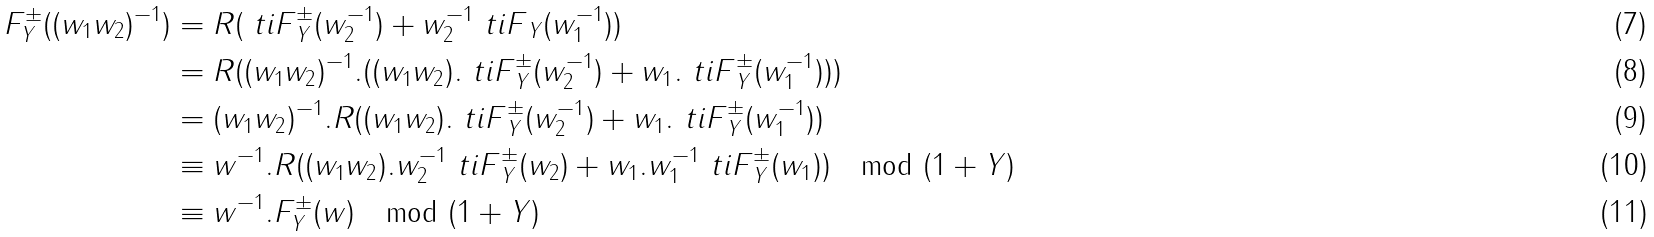<formula> <loc_0><loc_0><loc_500><loc_500>F _ { Y } ^ { \pm } ( ( w _ { 1 } w _ { 2 } ) ^ { - 1 } ) & = R ( { \ t i F } _ { Y } ^ { \pm } ( w _ { 2 } ^ { - 1 } ) + w _ { 2 } ^ { - 1 } { \ t i F } _ { Y } ( w _ { 1 } ^ { - 1 } ) ) \\ & = R ( ( w _ { 1 } w _ { 2 } ) ^ { - 1 } . ( ( w _ { 1 } w _ { 2 } ) . { \ t i F } _ { Y } ^ { \pm } ( w _ { 2 } ^ { - 1 } ) + w _ { 1 } . { \ t i F } _ { Y } ^ { \pm } ( w _ { 1 } ^ { - 1 } ) ) ) \\ & = ( w _ { 1 } w _ { 2 } ) ^ { - 1 } . R ( ( w _ { 1 } w _ { 2 } ) . { \ t i F } _ { Y } ^ { \pm } ( w _ { 2 } ^ { - 1 } ) + w _ { 1 } . { \ t i F } _ { Y } ^ { \pm } ( w _ { 1 } ^ { - 1 } ) ) \\ & \equiv w ^ { - 1 } . R ( ( w _ { 1 } w _ { 2 } ) . w _ { 2 } ^ { - 1 } { \ t i F } ^ { \pm } _ { Y } ( w _ { 2 } ) + w _ { 1 } . w _ { 1 } ^ { - 1 } { \ t i F } ^ { \pm } _ { Y } ( w _ { 1 } ) ) \mod ( 1 + Y ) \\ & \equiv w ^ { - 1 } . F ^ { \pm } _ { Y } ( w ) \mod ( 1 + Y )</formula> 